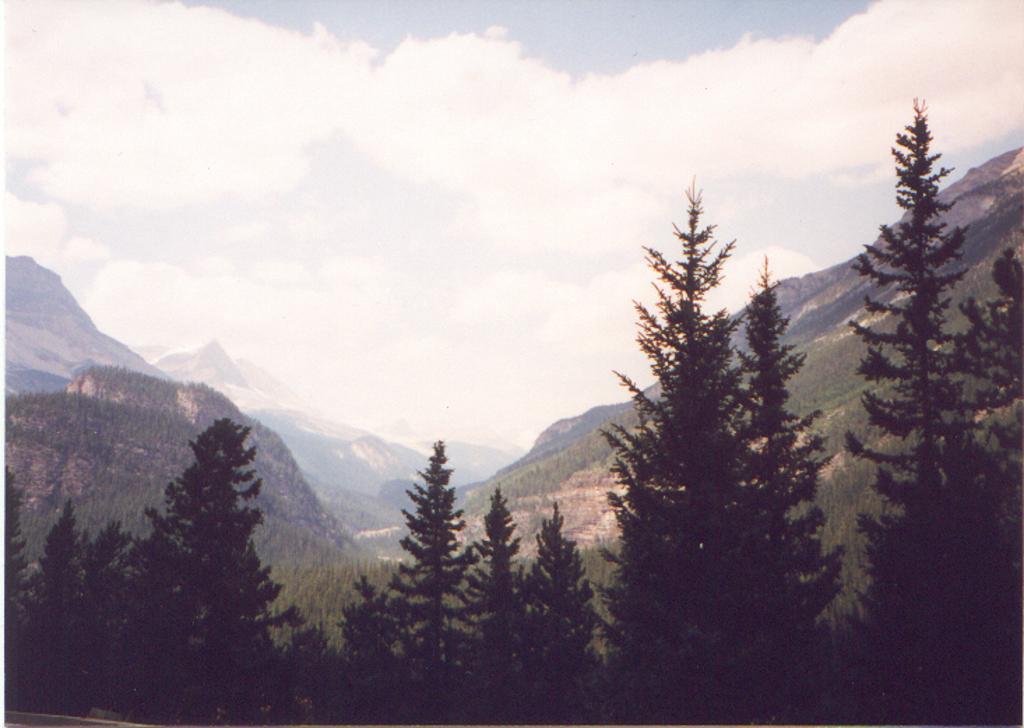Describe this image in one or two sentences. This is an outside view. At the bottom there are trees. In the background, I can see the mountains. At the top of the image I can see the sky and clouds. 